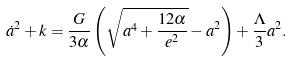Convert formula to latex. <formula><loc_0><loc_0><loc_500><loc_500>\dot { a } ^ { 2 } + k = \frac { G } { 3 \alpha } \left ( \sqrt { a ^ { 4 } + \frac { 1 2 \alpha } { e ^ { 2 } } } - a ^ { 2 } \right ) + \frac { \Lambda } { 3 } a ^ { 2 } .</formula> 